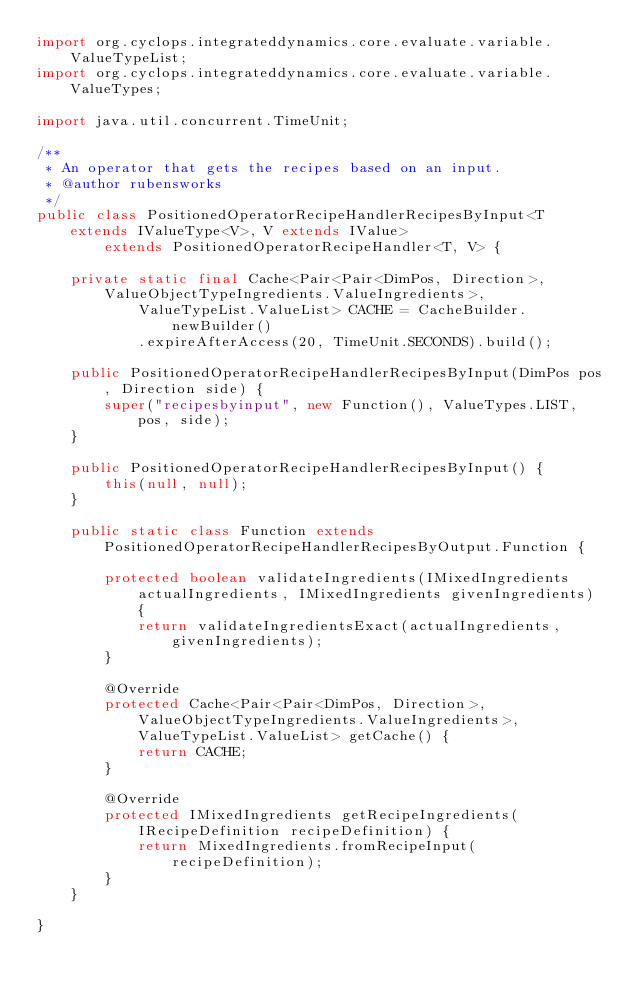Convert code to text. <code><loc_0><loc_0><loc_500><loc_500><_Java_>import org.cyclops.integrateddynamics.core.evaluate.variable.ValueTypeList;
import org.cyclops.integrateddynamics.core.evaluate.variable.ValueTypes;

import java.util.concurrent.TimeUnit;

/**
 * An operator that gets the recipes based on an input.
 * @author rubensworks
 */
public class PositionedOperatorRecipeHandlerRecipesByInput<T extends IValueType<V>, V extends IValue>
        extends PositionedOperatorRecipeHandler<T, V> {

    private static final Cache<Pair<Pair<DimPos, Direction>, ValueObjectTypeIngredients.ValueIngredients>,
            ValueTypeList.ValueList> CACHE = CacheBuilder.newBuilder()
            .expireAfterAccess(20, TimeUnit.SECONDS).build();

    public PositionedOperatorRecipeHandlerRecipesByInput(DimPos pos, Direction side) {
        super("recipesbyinput", new Function(), ValueTypes.LIST, pos, side);
    }

    public PositionedOperatorRecipeHandlerRecipesByInput() {
        this(null, null);
    }

    public static class Function extends PositionedOperatorRecipeHandlerRecipesByOutput.Function {

        protected boolean validateIngredients(IMixedIngredients actualIngredients, IMixedIngredients givenIngredients) {
            return validateIngredientsExact(actualIngredients, givenIngredients);
        }

        @Override
        protected Cache<Pair<Pair<DimPos, Direction>, ValueObjectTypeIngredients.ValueIngredients>, ValueTypeList.ValueList> getCache() {
            return CACHE;
        }

        @Override
        protected IMixedIngredients getRecipeIngredients(IRecipeDefinition recipeDefinition) {
            return MixedIngredients.fromRecipeInput(recipeDefinition);
        }
    }

}
</code> 